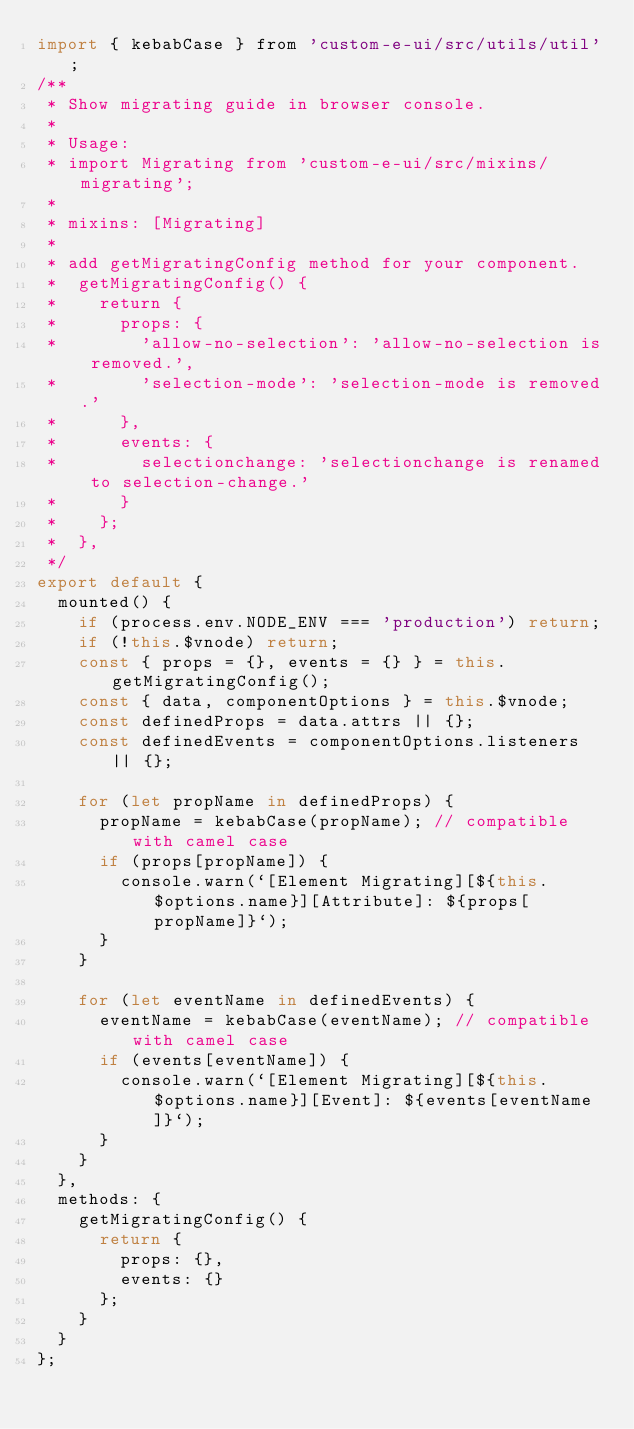Convert code to text. <code><loc_0><loc_0><loc_500><loc_500><_JavaScript_>import { kebabCase } from 'custom-e-ui/src/utils/util';
/**
 * Show migrating guide in browser console.
 *
 * Usage:
 * import Migrating from 'custom-e-ui/src/mixins/migrating';
 *
 * mixins: [Migrating]
 *
 * add getMigratingConfig method for your component.
 *  getMigratingConfig() {
 *    return {
 *      props: {
 *        'allow-no-selection': 'allow-no-selection is removed.',
 *        'selection-mode': 'selection-mode is removed.'
 *      },
 *      events: {
 *        selectionchange: 'selectionchange is renamed to selection-change.'
 *      }
 *    };
 *  },
 */
export default {
  mounted() {
    if (process.env.NODE_ENV === 'production') return;
    if (!this.$vnode) return;
    const { props = {}, events = {} } = this.getMigratingConfig();
    const { data, componentOptions } = this.$vnode;
    const definedProps = data.attrs || {};
    const definedEvents = componentOptions.listeners || {};

    for (let propName in definedProps) {
      propName = kebabCase(propName); // compatible with camel case
      if (props[propName]) {
        console.warn(`[Element Migrating][${this.$options.name}][Attribute]: ${props[propName]}`);
      }
    }

    for (let eventName in definedEvents) {
      eventName = kebabCase(eventName); // compatible with camel case
      if (events[eventName]) {
        console.warn(`[Element Migrating][${this.$options.name}][Event]: ${events[eventName]}`);
      }
    }
  },
  methods: {
    getMigratingConfig() {
      return {
        props: {},
        events: {}
      };
    }
  }
};
</code> 